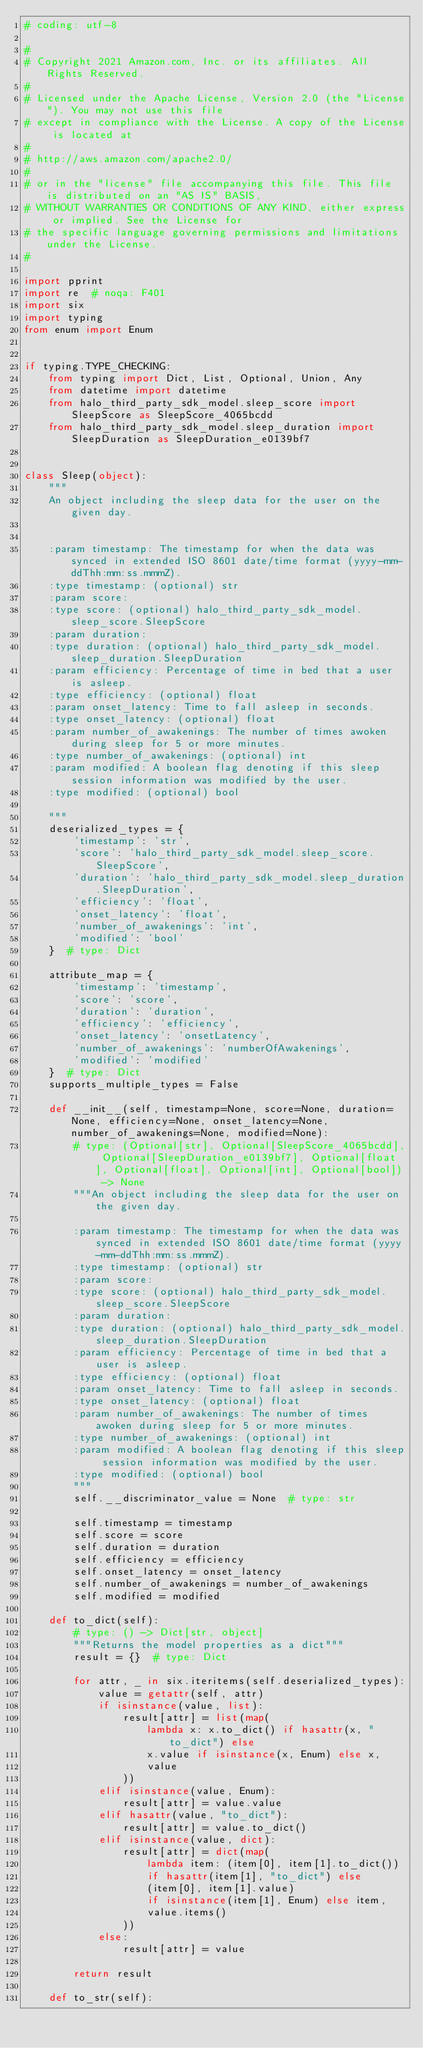<code> <loc_0><loc_0><loc_500><loc_500><_Python_># coding: utf-8

#
# Copyright 2021 Amazon.com, Inc. or its affiliates. All Rights Reserved.
#
# Licensed under the Apache License, Version 2.0 (the "License"). You may not use this file
# except in compliance with the License. A copy of the License is located at
#
# http://aws.amazon.com/apache2.0/
#
# or in the "license" file accompanying this file. This file is distributed on an "AS IS" BASIS,
# WITHOUT WARRANTIES OR CONDITIONS OF ANY KIND, either express or implied. See the License for
# the specific language governing permissions and limitations under the License.
#

import pprint
import re  # noqa: F401
import six
import typing
from enum import Enum


if typing.TYPE_CHECKING:
    from typing import Dict, List, Optional, Union, Any
    from datetime import datetime
    from halo_third_party_sdk_model.sleep_score import SleepScore as SleepScore_4065bcdd
    from halo_third_party_sdk_model.sleep_duration import SleepDuration as SleepDuration_e0139bf7


class Sleep(object):
    """
    An object including the sleep data for the user on the given day.


    :param timestamp: The timestamp for when the data was synced in extended ISO 8601 date/time format (yyyy-mm-ddThh:mm:ss.mmmZ).
    :type timestamp: (optional) str
    :param score: 
    :type score: (optional) halo_third_party_sdk_model.sleep_score.SleepScore
    :param duration: 
    :type duration: (optional) halo_third_party_sdk_model.sleep_duration.SleepDuration
    :param efficiency: Percentage of time in bed that a user is asleep.
    :type efficiency: (optional) float
    :param onset_latency: Time to fall asleep in seconds.
    :type onset_latency: (optional) float
    :param number_of_awakenings: The number of times awoken during sleep for 5 or more minutes.
    :type number_of_awakenings: (optional) int
    :param modified: A boolean flag denoting if this sleep session information was modified by the user.
    :type modified: (optional) bool

    """
    deserialized_types = {
        'timestamp': 'str',
        'score': 'halo_third_party_sdk_model.sleep_score.SleepScore',
        'duration': 'halo_third_party_sdk_model.sleep_duration.SleepDuration',
        'efficiency': 'float',
        'onset_latency': 'float',
        'number_of_awakenings': 'int',
        'modified': 'bool'
    }  # type: Dict

    attribute_map = {
        'timestamp': 'timestamp',
        'score': 'score',
        'duration': 'duration',
        'efficiency': 'efficiency',
        'onset_latency': 'onsetLatency',
        'number_of_awakenings': 'numberOfAwakenings',
        'modified': 'modified'
    }  # type: Dict
    supports_multiple_types = False

    def __init__(self, timestamp=None, score=None, duration=None, efficiency=None, onset_latency=None, number_of_awakenings=None, modified=None):
        # type: (Optional[str], Optional[SleepScore_4065bcdd], Optional[SleepDuration_e0139bf7], Optional[float], Optional[float], Optional[int], Optional[bool]) -> None
        """An object including the sleep data for the user on the given day.

        :param timestamp: The timestamp for when the data was synced in extended ISO 8601 date/time format (yyyy-mm-ddThh:mm:ss.mmmZ).
        :type timestamp: (optional) str
        :param score: 
        :type score: (optional) halo_third_party_sdk_model.sleep_score.SleepScore
        :param duration: 
        :type duration: (optional) halo_third_party_sdk_model.sleep_duration.SleepDuration
        :param efficiency: Percentage of time in bed that a user is asleep.
        :type efficiency: (optional) float
        :param onset_latency: Time to fall asleep in seconds.
        :type onset_latency: (optional) float
        :param number_of_awakenings: The number of times awoken during sleep for 5 or more minutes.
        :type number_of_awakenings: (optional) int
        :param modified: A boolean flag denoting if this sleep session information was modified by the user.
        :type modified: (optional) bool
        """
        self.__discriminator_value = None  # type: str

        self.timestamp = timestamp
        self.score = score
        self.duration = duration
        self.efficiency = efficiency
        self.onset_latency = onset_latency
        self.number_of_awakenings = number_of_awakenings
        self.modified = modified

    def to_dict(self):
        # type: () -> Dict[str, object]
        """Returns the model properties as a dict"""
        result = {}  # type: Dict

        for attr, _ in six.iteritems(self.deserialized_types):
            value = getattr(self, attr)
            if isinstance(value, list):
                result[attr] = list(map(
                    lambda x: x.to_dict() if hasattr(x, "to_dict") else
                    x.value if isinstance(x, Enum) else x,
                    value
                ))
            elif isinstance(value, Enum):
                result[attr] = value.value
            elif hasattr(value, "to_dict"):
                result[attr] = value.to_dict()
            elif isinstance(value, dict):
                result[attr] = dict(map(
                    lambda item: (item[0], item[1].to_dict())
                    if hasattr(item[1], "to_dict") else
                    (item[0], item[1].value)
                    if isinstance(item[1], Enum) else item,
                    value.items()
                ))
            else:
                result[attr] = value

        return result

    def to_str(self):</code> 